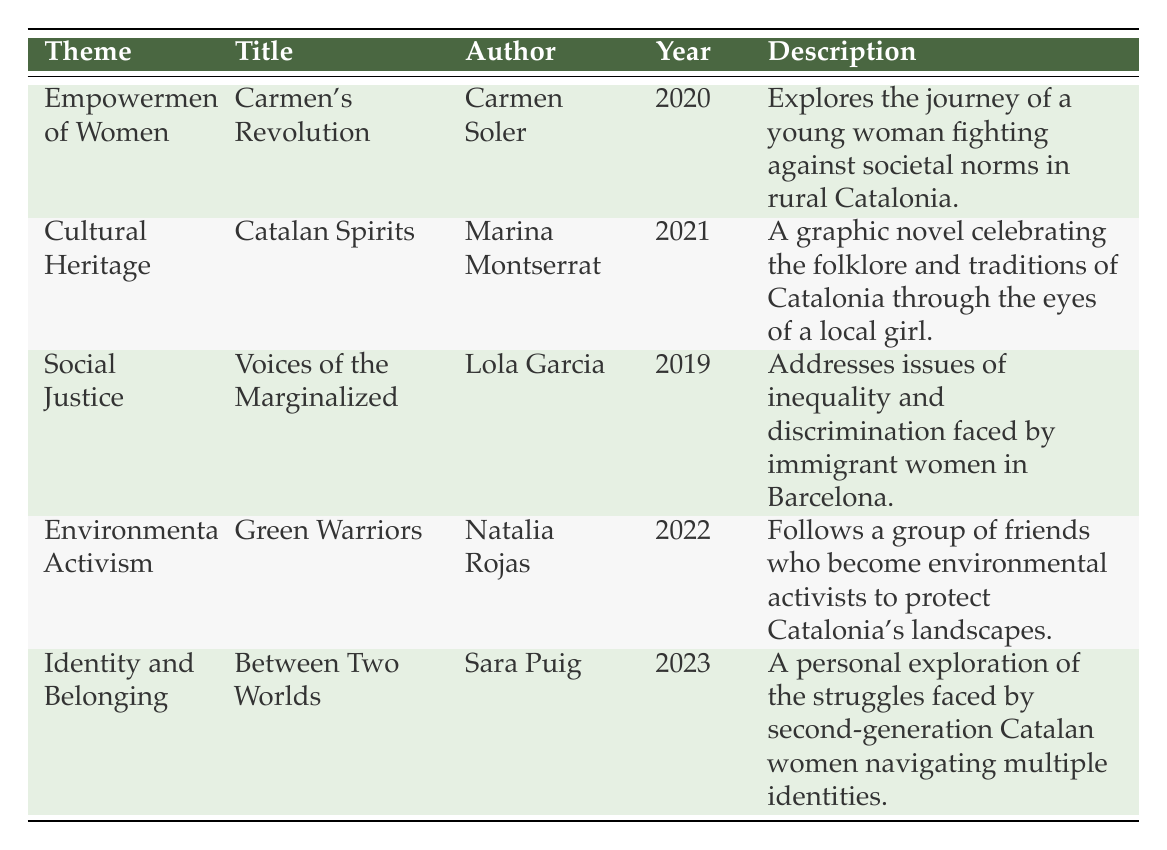What is the title of the graphic novel that explores the empowerment of women? From the table, the "Theme" column has a row titled "Empowerment of Women," which corresponds to "Carmen's Revolution" in the "Title" column.
Answer: Carmen's Revolution Who is the author of "Catalan Spirits"? Looking at the row for "Catalan Spirits," the "Author" column reveals that it was written by Marina Montserrat.
Answer: Marina Montserrat Is "Green Warriors" a graphic novel that addresses social justice themes? The row for "Green Warriors" shows that its theme is "Environmental Activism," not social justice. Therefore, it does not address social justice themes.
Answer: No What year was "Voices of the Marginalized" published? Referring to the table, the "Year" column for "Voices of the Marginalized" indicates it was published in 2019.
Answer: 2019 How many graphic novels in the table focus on women's empowerment or identity themes? The table shows two themes that focus on women's empowerment and identity: "Empowerment of Women" (Carmen's Revolution) and "Identity and Belonging" (Between Two Worlds). Thus, there are two graphic novels that meet this criterion.
Answer: 2 Which graphic novel was published most recently, and what is its theme? By examining the "Year" column, "Between Two Worlds" published in 2023 is the most recent, with the theme of "Identity and Belonging."
Answer: Between Two Worlds, Identity and Belonging Are there any graphic novels in the table that celebrate Catalan folklore? The table indicates that "Catalan Spirits," with the theme "Cultural Heritage," celebrates folklore and traditions of Catalonia. Therefore, the answer is yes.
Answer: Yes If we consider the themes covered in the table, how many of them relate to environmental topics? In the table, only one graphic novel, "Green Warriors," directly relates to environmental activism. Therefore, there is just one contribution to this theme.
Answer: 1 What is the theme of the graphic novel authored by Lola Garcia? The row under Lola Garcia shows that her graphic novel, "Voices of the Marginalized," addresses "Social Justice."
Answer: Social Justice Which author has a graphic novel exploring identity and belonging? "Between Two Worlds" by Sara Puig focuses on identity and belonging according to the data in the table.
Answer: Sara Puig 